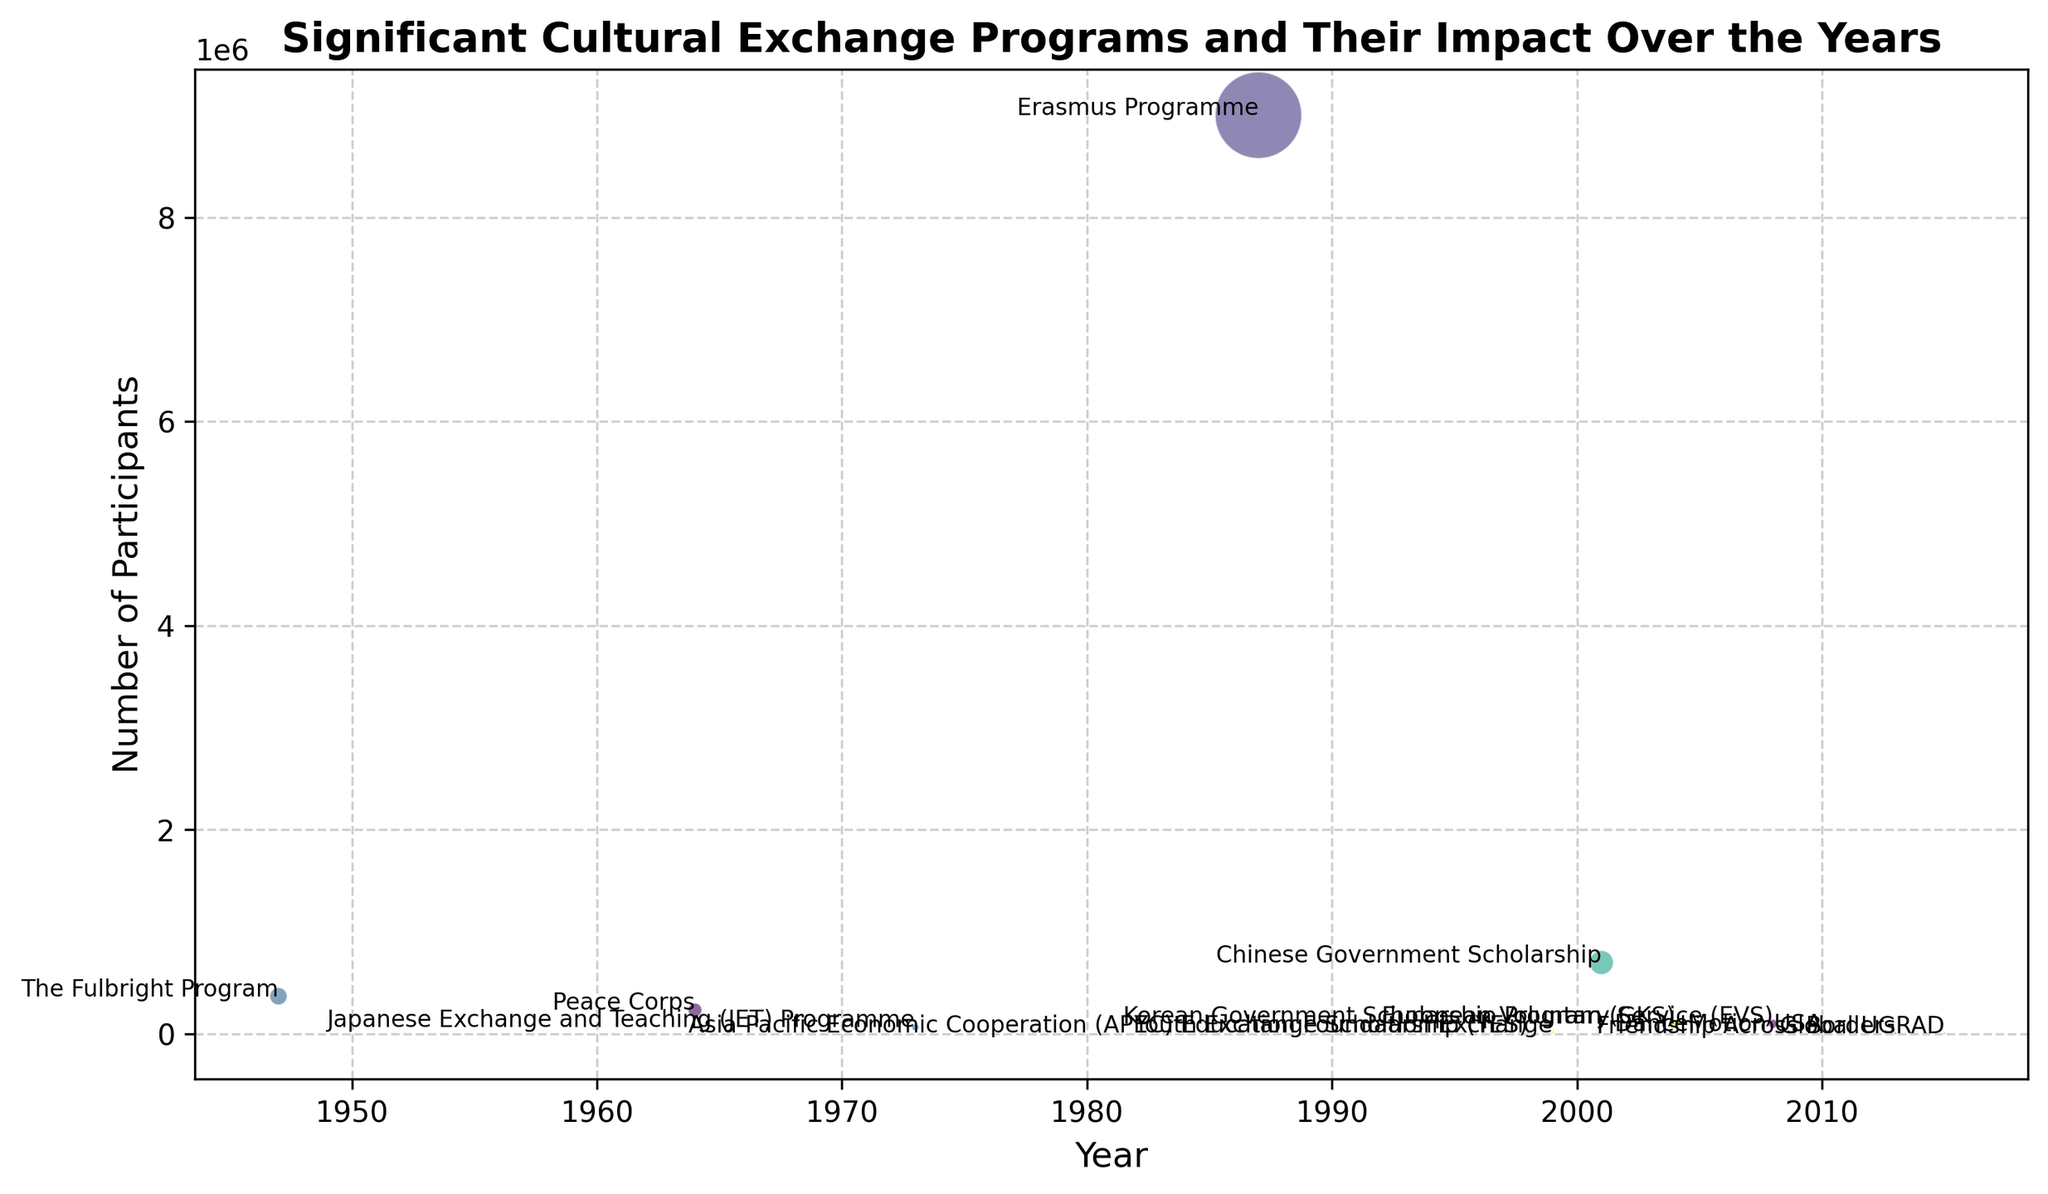What's the name of the cultural exchange program with the highest number of participants? The program with the highest number of participants can be identified by looking for the data point that is visually the largest on the y-axis, which represents participants. In the figure, the Erasmus Programme in 1987 has the maximum number of participants (9,000,000).
Answer: Erasmus Programme Which program had more participants, the Fulbright Program or the Chinese Government Scholarship? Compare the y-axis values (participant numbers) for the data points representing the Fulbright Program (1947) and the Chinese Government Scholarship (2001). The Fulbright Program has 370,000 participants, and the Chinese Government Scholarship has 700,000 participants.
Answer: Chinese Government Scholarship What was the total number of participants in the JET Programme and the Erasmus Programme? Find the y-axis values for the JET Programme (1973) and Erasmus Programme (1987). The JET Programme had 66,000 participants, and the Erasmus Programme had 9,000,000 participants. Add these two numbers to get the total. 66,000 + 9,000,000 = 9,066,000 participants.
Answer: 9,066,000 Which program, initiated before 2000, had the least number of participants? Check the data points before the year 2000, and identify the smallest value on the y-axis. The participant number for Youth Exchange Scholarship (YES) in 1998 is 12,000, which is lower than any other program before 2000.
Answer: Youth Exchange Scholarship (YES) What is the average number of participants for the programs initiated in 2010, 2013, and 2015? Identify the participant numbers for the mentioned years: DanceMotion USA (2010) has 25,000 participants, Friendship Across Borders (2013) has 8,000 participants, and Global UGRAD (2015) has 8,500 participants. Calculate the average: (25,000 + 8,000 + 8,500) / 3 = 41,500 / 3 ≈ 13,833 participants.
Answer: 13,833 How does the number of participants in the Peace Corps compare to those in the Korean Government Scholarship Program (GKS)? Look at the data points for the Peace Corps (1964) and Korean Government Scholarship Program (GKS) (2004). Peace Corps has 235,000 participants, while Korean Government Scholarship Program (GKS) has 100,000 participants.
Answer: Peace Corps has more participants Which program started in the earliest year, and how many participants did it have? Identify the earliest year on the x-axis, which is 1947. The Fulbright Program started in this year and had 370,000 participants.
Answer: The Fulbright Program with 370,000 participants What is the difference in the number of participants between The Fulbright Program and DanceMotion USA? Find the number of participants for both programs: The Fulbright Program (1947) has 370,000 participants, and DanceMotion USA (2010) has 25,000 participants. Subtract the smaller number from the larger number: 370,000 - 25,000 = 345,000 participants.
Answer: 345,000 Which two programs have the closest number of participants? Compare the number of participants for all programs. The closest numbers are between Youth Exchange Scholarship (YES) in 1998 with 12,000 participants and APEC Education Foundation Exchange in 1999 with 15,000 participants, which have a difference of 3,000 participants.
Answer: Youth Exchange Scholarship (YES) and APEC Education Foundation Exchange 